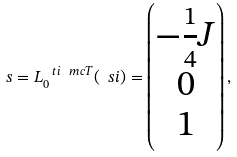Convert formula to latex. <formula><loc_0><loc_0><loc_500><loc_500>s = L _ { 0 } ^ { \ t i { \ m c { T } } } ( \ s i ) = \begin{pmatrix} - \frac { 1 } { 4 } J \\ 0 \\ 1 \end{pmatrix} ,</formula> 